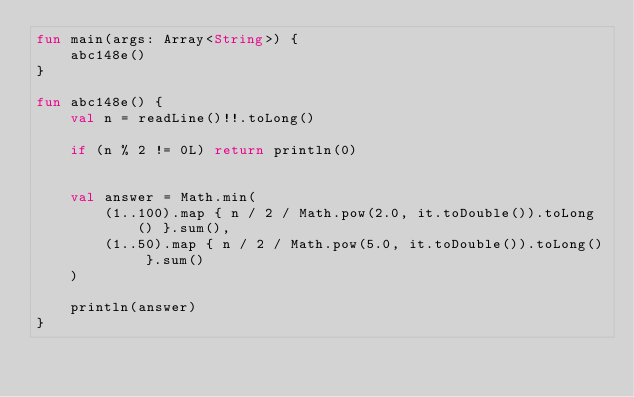<code> <loc_0><loc_0><loc_500><loc_500><_Kotlin_>fun main(args: Array<String>) {
    abc148e()
}

fun abc148e() {
    val n = readLine()!!.toLong()

    if (n % 2 != 0L) return println(0)


    val answer = Math.min(
        (1..100).map { n / 2 / Math.pow(2.0, it.toDouble()).toLong() }.sum(),
        (1..50).map { n / 2 / Math.pow(5.0, it.toDouble()).toLong() }.sum()
    )

    println(answer)
}
</code> 